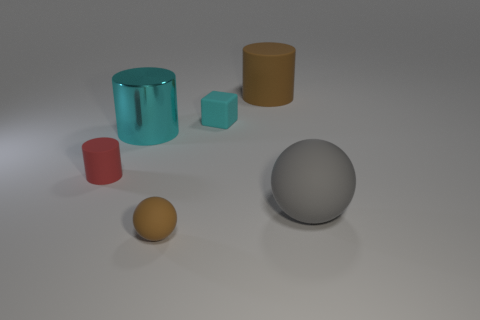Are there any other things that have the same material as the large cyan object?
Ensure brevity in your answer.  No. What number of big gray rubber things have the same shape as the red object?
Make the answer very short. 0. What number of brown metallic balls are there?
Ensure brevity in your answer.  0. Do the cyan object on the left side of the cyan rubber block and the tiny brown thing have the same shape?
Your answer should be very brief. No. What material is the other cylinder that is the same size as the cyan cylinder?
Ensure brevity in your answer.  Rubber. Is there a cyan cube that has the same material as the brown cylinder?
Your response must be concise. Yes. There is a red object; does it have the same shape as the brown object that is in front of the gray matte sphere?
Provide a short and direct response. No. How many brown objects are both in front of the big cyan cylinder and behind the big sphere?
Your response must be concise. 0. Are the small cyan object and the large thing that is behind the cyan rubber thing made of the same material?
Your answer should be very brief. Yes. Is the number of tiny spheres that are behind the cyan metallic cylinder the same as the number of big brown rubber cylinders?
Offer a terse response. No. 